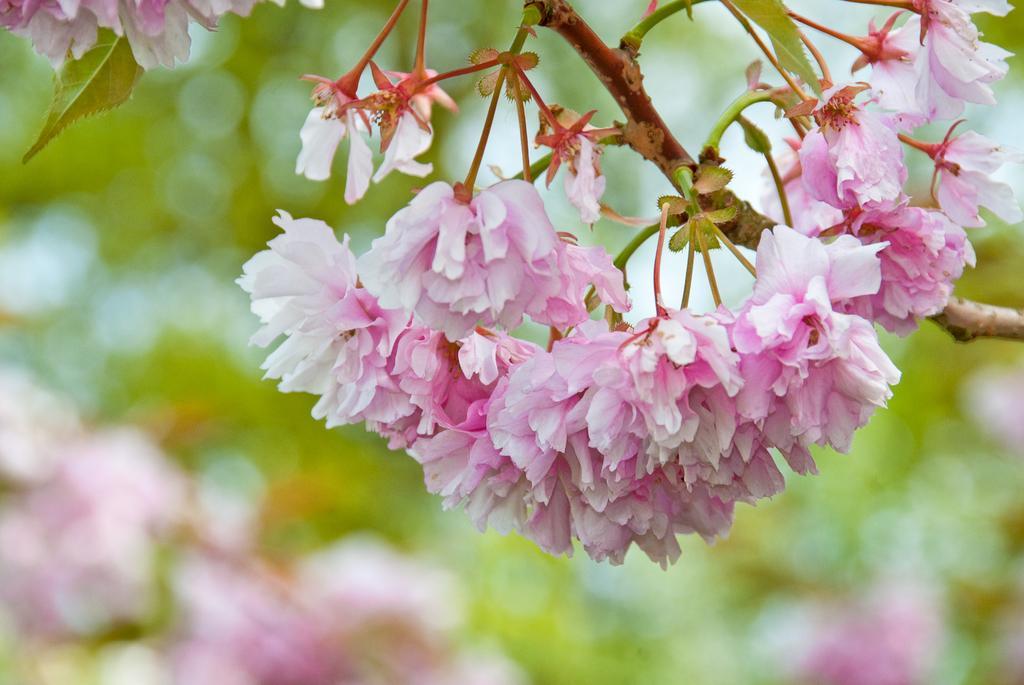Could you give a brief overview of what you see in this image? In this image we can see many flowers to a tree. There is a blur background in the image. 